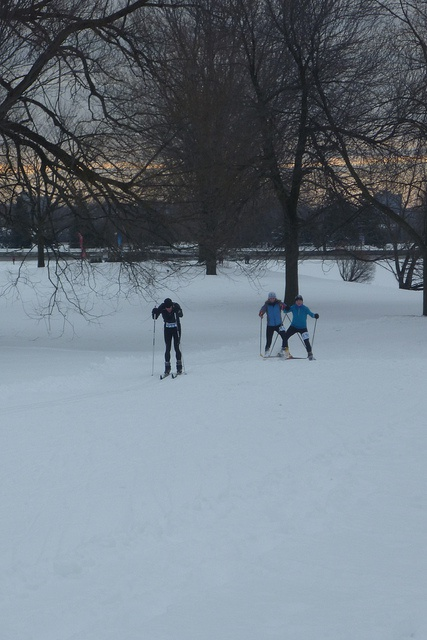Describe the objects in this image and their specific colors. I can see people in black, darkgray, and gray tones, people in black, blue, darkblue, and gray tones, people in black, blue, navy, and gray tones, skis in black, gray, darkgray, and blue tones, and skis in black, gray, and darkgray tones in this image. 